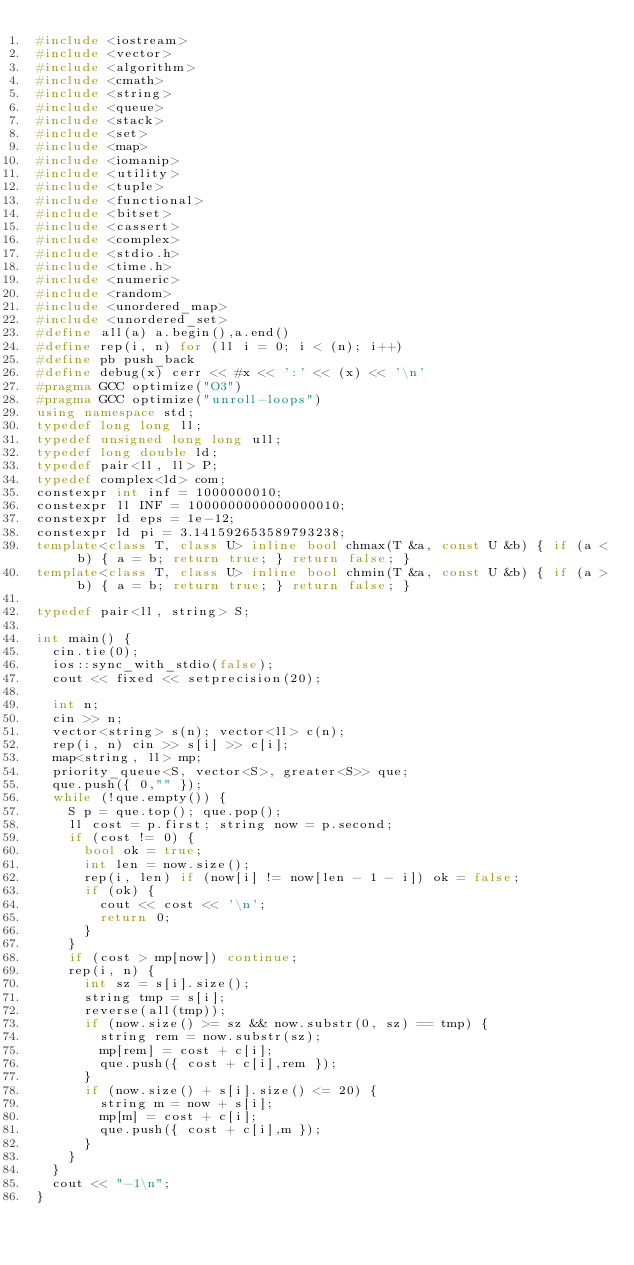<code> <loc_0><loc_0><loc_500><loc_500><_C++_>#include <iostream>
#include <vector>
#include <algorithm>
#include <cmath>
#include <string>
#include <queue>
#include <stack>
#include <set>
#include <map>
#include <iomanip>
#include <utility>
#include <tuple>
#include <functional>
#include <bitset>
#include <cassert>
#include <complex>
#include <stdio.h>
#include <time.h>
#include <numeric>
#include <random>
#include <unordered_map>
#include <unordered_set>
#define all(a) a.begin(),a.end()
#define rep(i, n) for (ll i = 0; i < (n); i++)
#define pb push_back
#define debug(x) cerr << #x << ':' << (x) << '\n'
#pragma GCC optimize("O3")
#pragma GCC optimize("unroll-loops")
using namespace std;
typedef long long ll;
typedef unsigned long long ull;
typedef long double ld;
typedef pair<ll, ll> P;
typedef complex<ld> com;
constexpr int inf = 1000000010;
constexpr ll INF = 1000000000000000010;
constexpr ld eps = 1e-12;
constexpr ld pi = 3.141592653589793238;
template<class T, class U> inline bool chmax(T &a, const U &b) { if (a < b) { a = b; return true; } return false; }
template<class T, class U> inline bool chmin(T &a, const U &b) { if (a > b) { a = b; return true; } return false; }

typedef pair<ll, string> S;

int main() {
	cin.tie(0);
	ios::sync_with_stdio(false);
	cout << fixed << setprecision(20);

	int n;
	cin >> n;
	vector<string> s(n); vector<ll> c(n);
	rep(i, n) cin >> s[i] >> c[i];
	map<string, ll> mp;
	priority_queue<S, vector<S>, greater<S>> que;
	que.push({ 0,"" });
	while (!que.empty()) {
		S p = que.top(); que.pop();
		ll cost = p.first; string now = p.second;
		if (cost != 0) {
			bool ok = true;
			int len = now.size();
			rep(i, len) if (now[i] != now[len - 1 - i]) ok = false;
			if (ok) {
				cout << cost << '\n';
				return 0;
			}
		}
		if (cost > mp[now]) continue;
		rep(i, n) {
			int sz = s[i].size();
			string tmp = s[i];
			reverse(all(tmp));
			if (now.size() >= sz && now.substr(0, sz) == tmp) {
				string rem = now.substr(sz);
				mp[rem] = cost + c[i];
				que.push({ cost + c[i],rem });
			}
			if (now.size() + s[i].size() <= 20) {
				string m = now + s[i];
				mp[m] = cost + c[i];
				que.push({ cost + c[i],m });
			}
		}
	}
	cout << "-1\n";
}</code> 